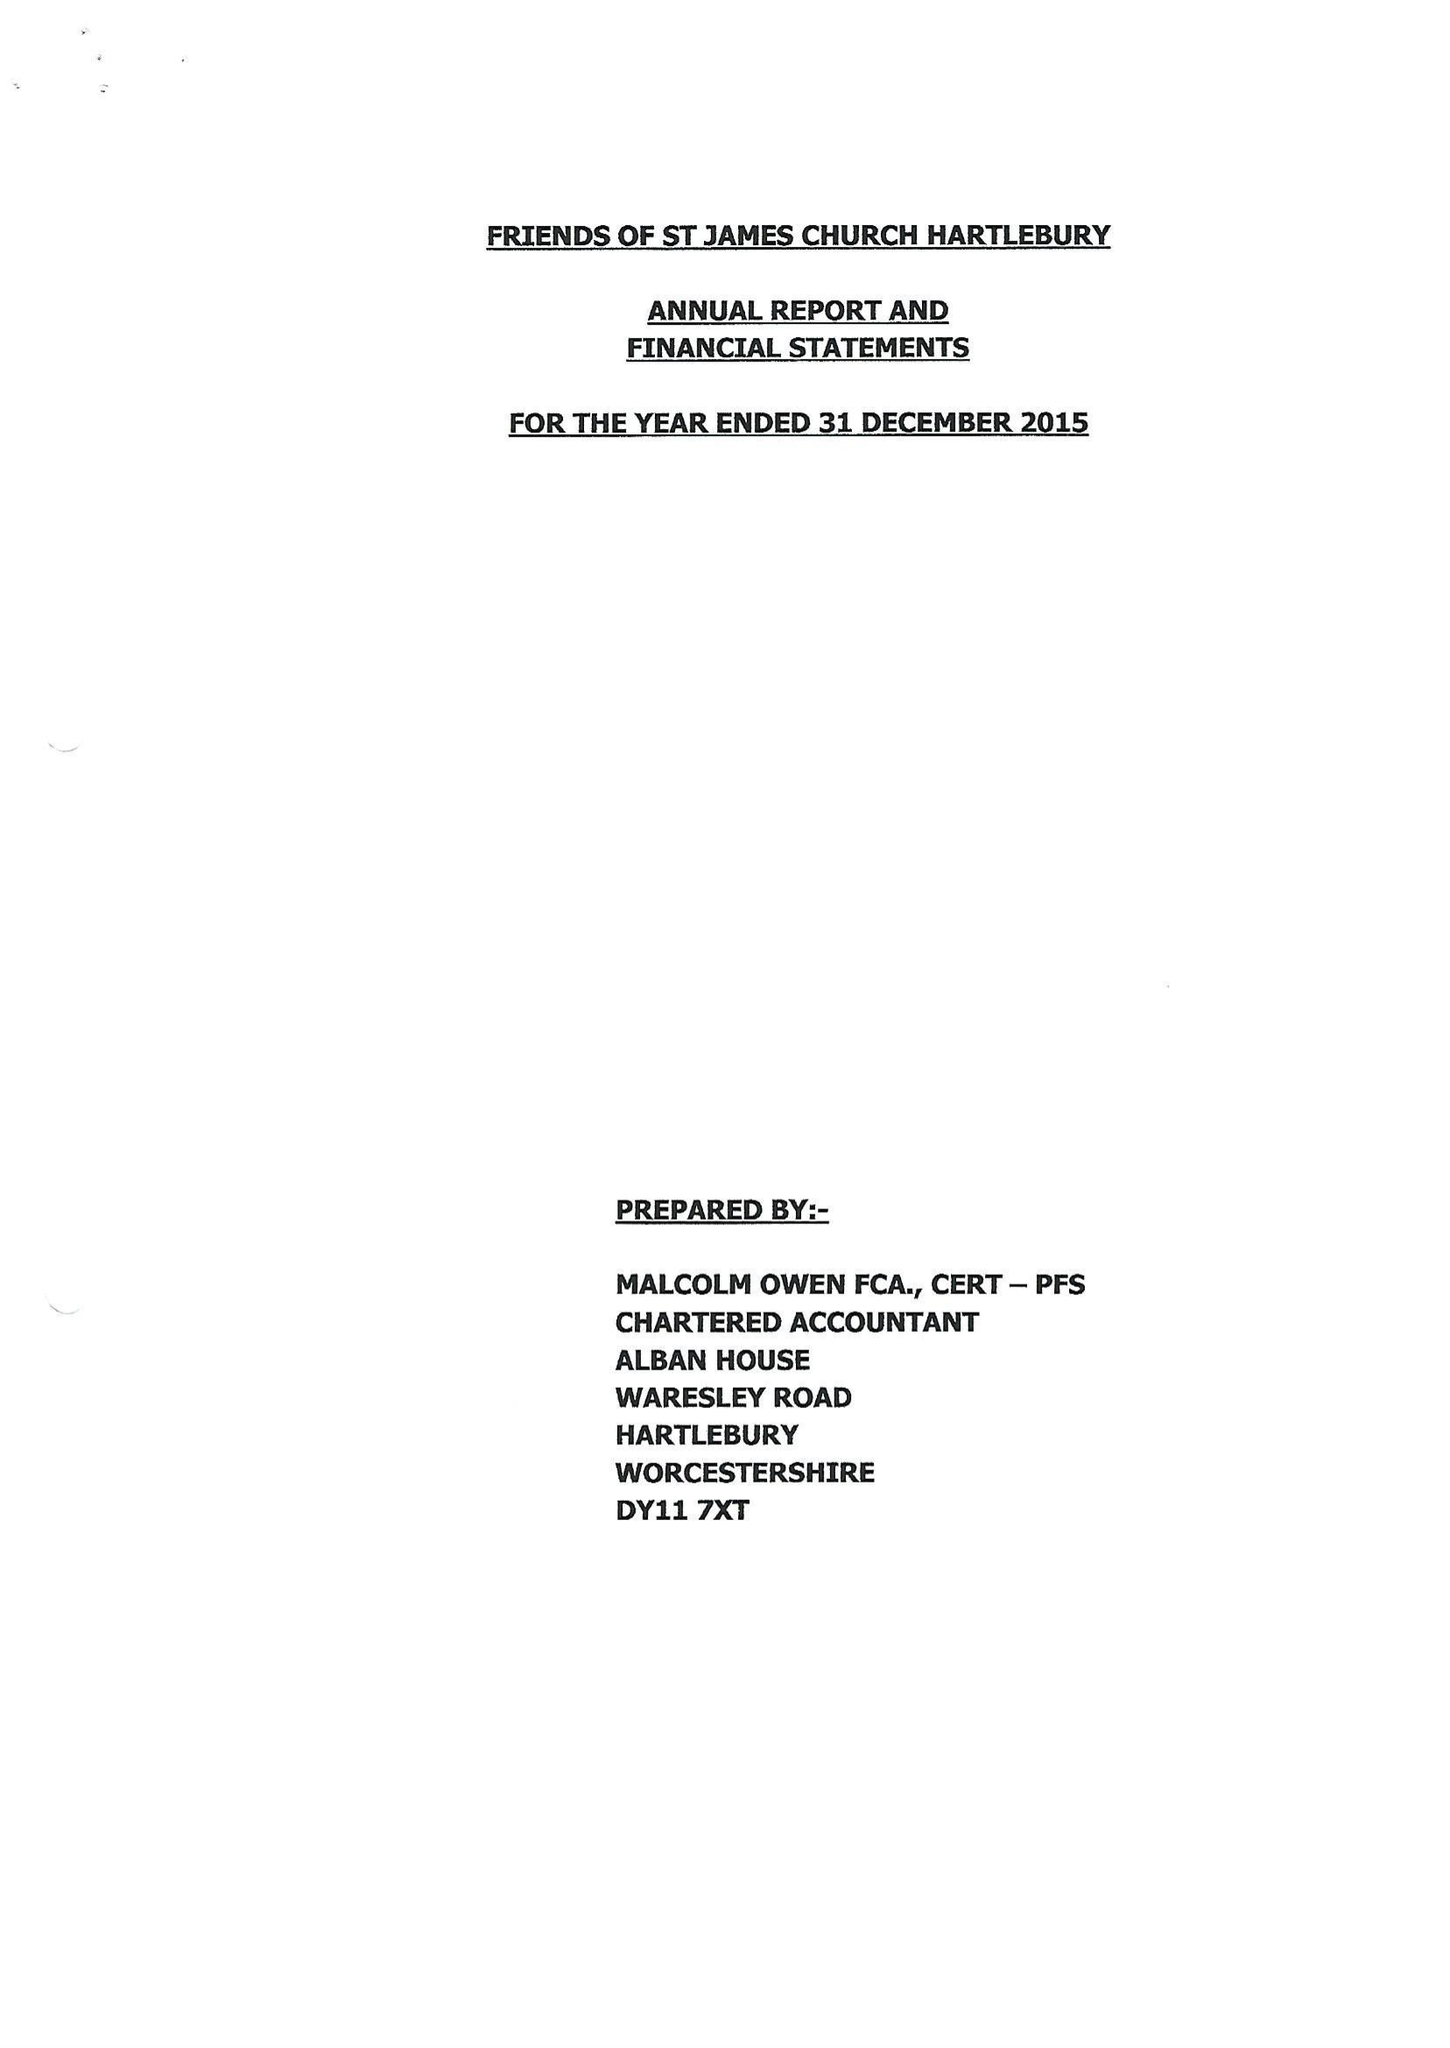What is the value for the charity_number?
Answer the question using a single word or phrase. 1156410 